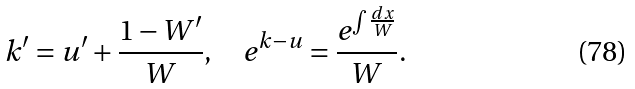<formula> <loc_0><loc_0><loc_500><loc_500>k ^ { \prime } = u ^ { \prime } + \frac { 1 - W ^ { \prime } } W , \quad e ^ { k - u } = \frac { e ^ { \int \frac { d x } W } } W .</formula> 